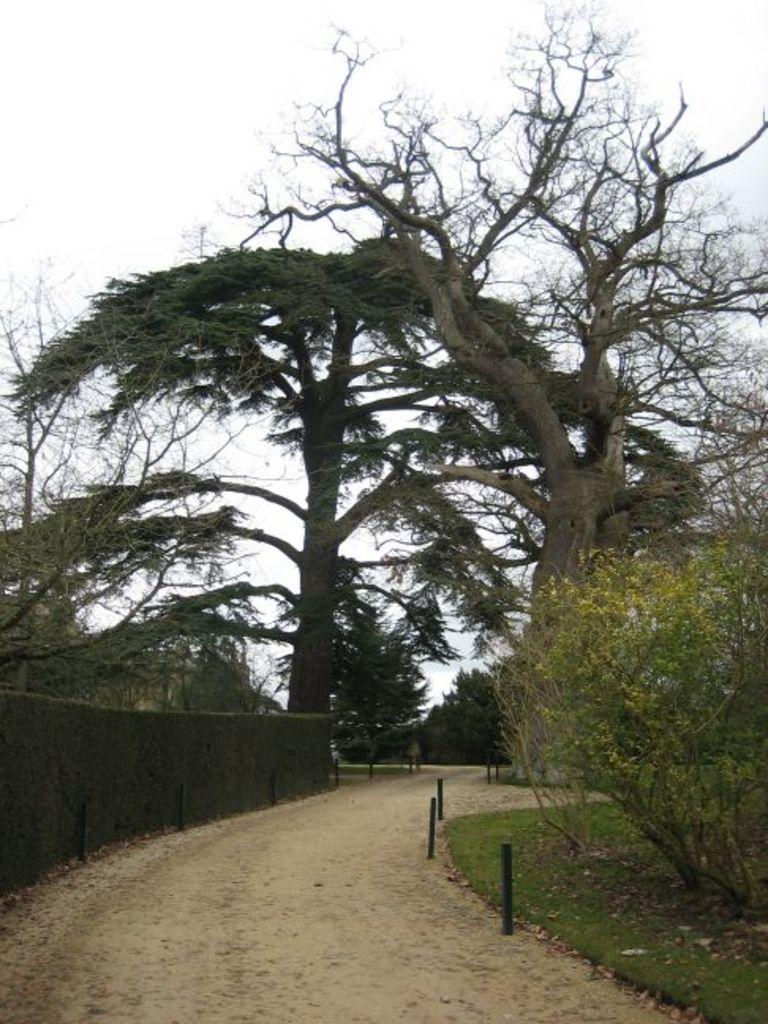What type of vegetation is in the middle of the image? There are trees in the middle of the image. What can be seen at the bottom of the image? There are plants and grass at the bottom of the image, as well as a road. What is visible at the top of the image? The sky is visible at the top of the image. What type of furniture is being used in the bath in the image? There is no furniture or bath present in the image; it features trees, plants, grass, a road, and the sky. Can you tell me how many chess pieces are visible on the road in the image? There are no chess pieces visible in the image; it features trees, plants, grass, a road, and the sky. 